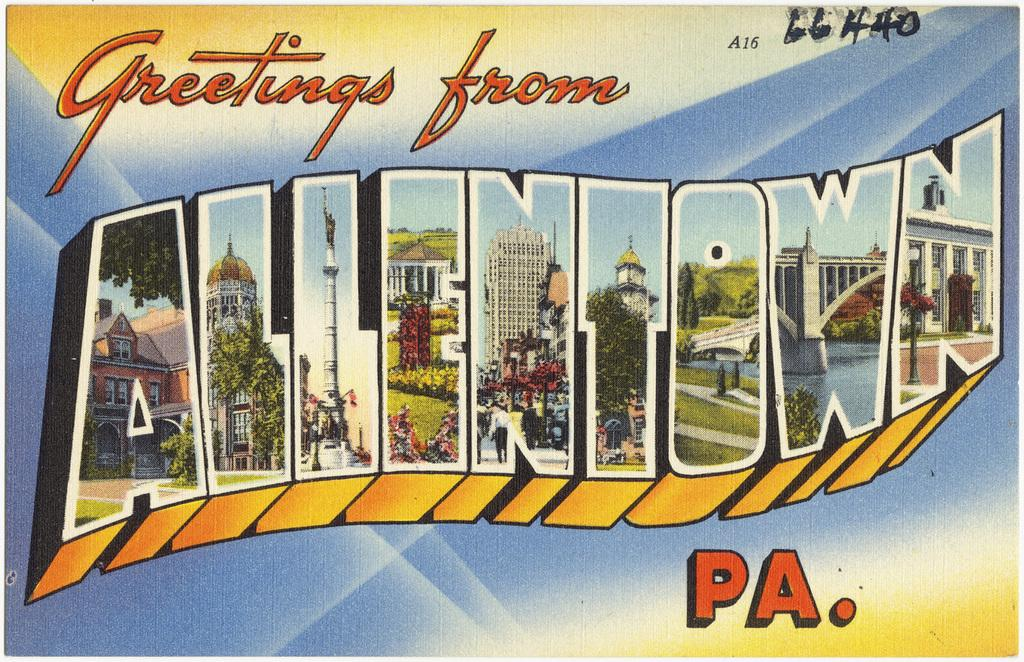What is featured on the poster in the image? There is a poster in the image, and it contains a view of buildings and trees. How are the buildings and trees represented on the poster? The view of buildings and trees is depicted using letters. Are there any other letters on the poster besides those representing the buildings and trees? Yes, there are other letters on the poster. What type of amusement can be seen in the image? There is no amusement present in the image; it features a poster with a view of buildings and trees depicted using letters. What is the cream used for in the image? There is no cream present in the image. 